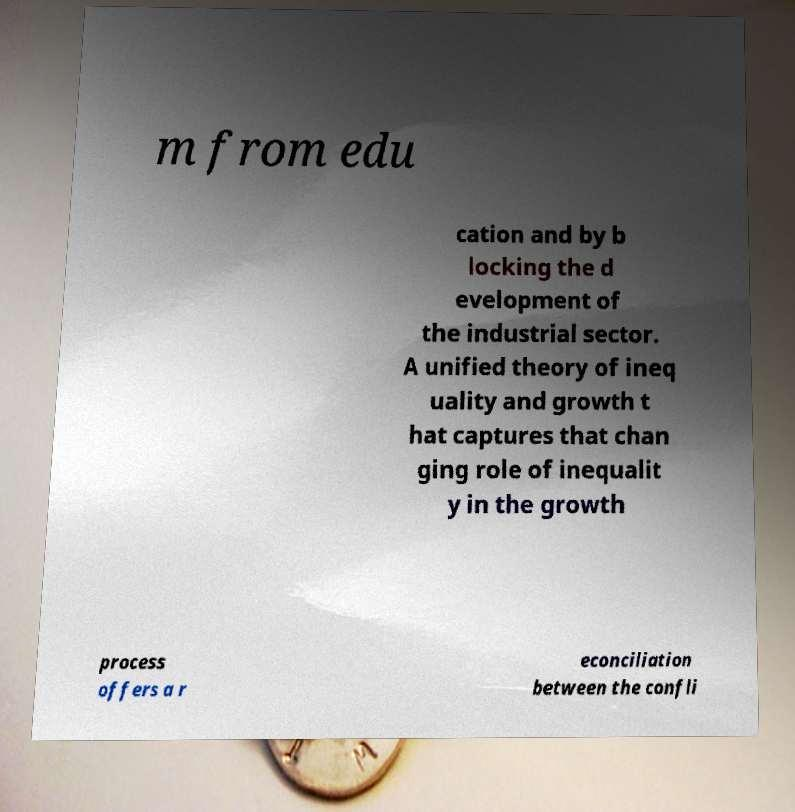Please identify and transcribe the text found in this image. m from edu cation and by b locking the d evelopment of the industrial sector. A unified theory of ineq uality and growth t hat captures that chan ging role of inequalit y in the growth process offers a r econciliation between the confli 